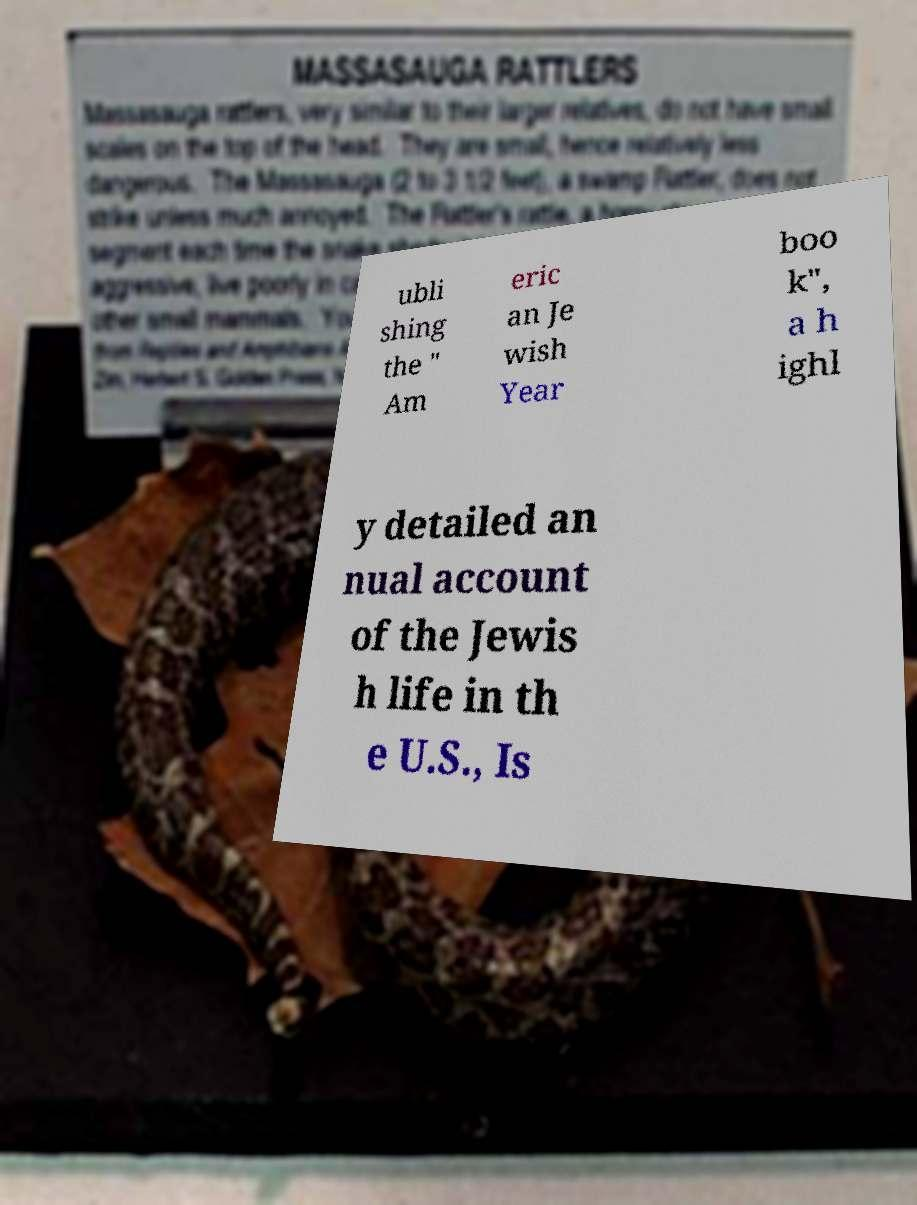I need the written content from this picture converted into text. Can you do that? ubli shing the " Am eric an Je wish Year boo k", a h ighl y detailed an nual account of the Jewis h life in th e U.S., Is 